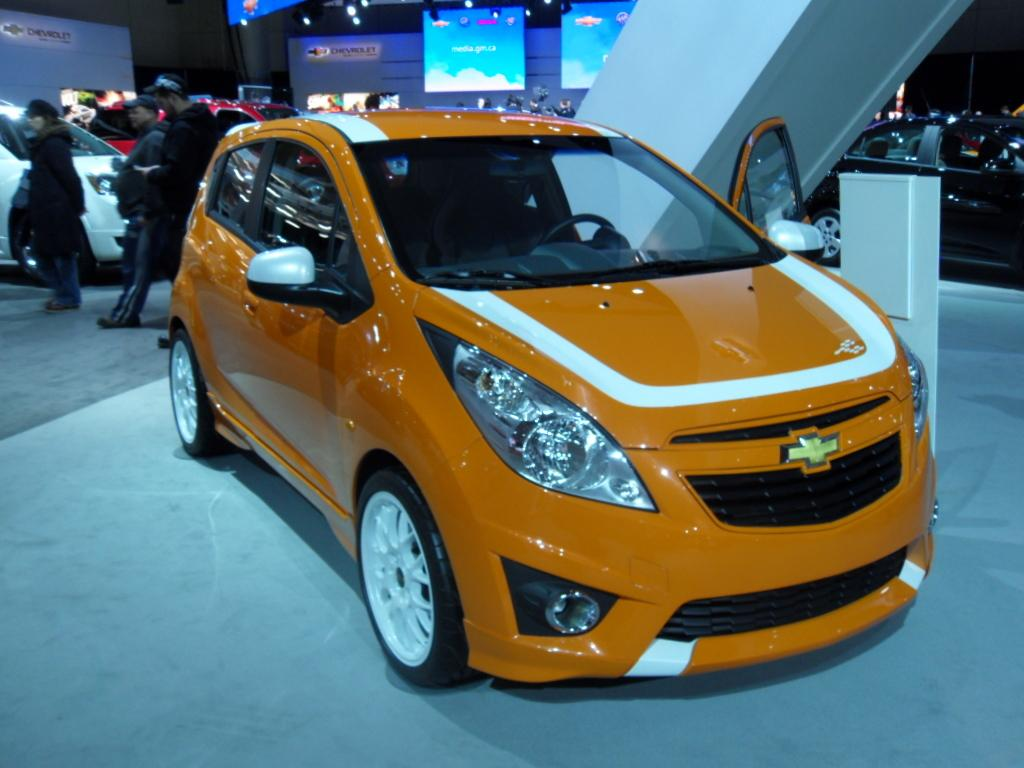What type of vehicles can be seen in the image? There are cars in the image. Where are the three persons located in the image? The three persons are standing on the left side of the image. What can be seen in the background of the image? There are boards and lights visible in the background of the image. What type of advice does the grandfather give to the leaf in the image? There is no grandfather or leaf present in the image. 